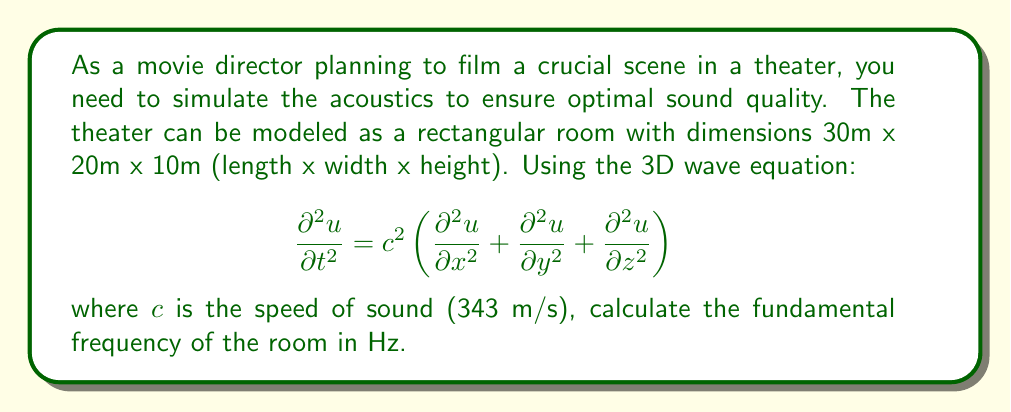Help me with this question. To solve this problem, we'll follow these steps:

1) The fundamental frequency of a rectangular room is given by:

   $$ f = \frac{c}{2} \sqrt{\left(\frac{n_x}{L_x}\right)^2 + \left(\frac{n_y}{L_y}\right)^2 + \left(\frac{n_z}{L_z}\right)^2} $$

   where $n_x$, $n_y$, and $n_z$ are the mode numbers (all 1 for the fundamental frequency), and $L_x$, $L_y$, and $L_z$ are the room dimensions.

2) We have:
   $c = 343$ m/s
   $L_x = 30$ m
   $L_y = 20$ m
   $L_z = 10$ m
   $n_x = n_y = n_z = 1$

3) Substituting these values:

   $$ f = \frac{343}{2} \sqrt{\left(\frac{1}{30}\right)^2 + \left(\frac{1}{20}\right)^2 + \left(\frac{1}{10}\right)^2} $$

4) Simplifying under the square root:

   $$ f = \frac{343}{2} \sqrt{\frac{1}{900} + \frac{1}{400} + \frac{1}{100}} $$

5) Calculating:

   $$ f = \frac{343}{2} \sqrt{0.001111 + 0.0025 + 0.01} = \frac{343}{2} \sqrt{0.013611} $$

6) Finalizing the calculation:

   $$ f = 171.5 \sqrt{0.013611} \approx 20.01 \text{ Hz} $$
Answer: 20.01 Hz 